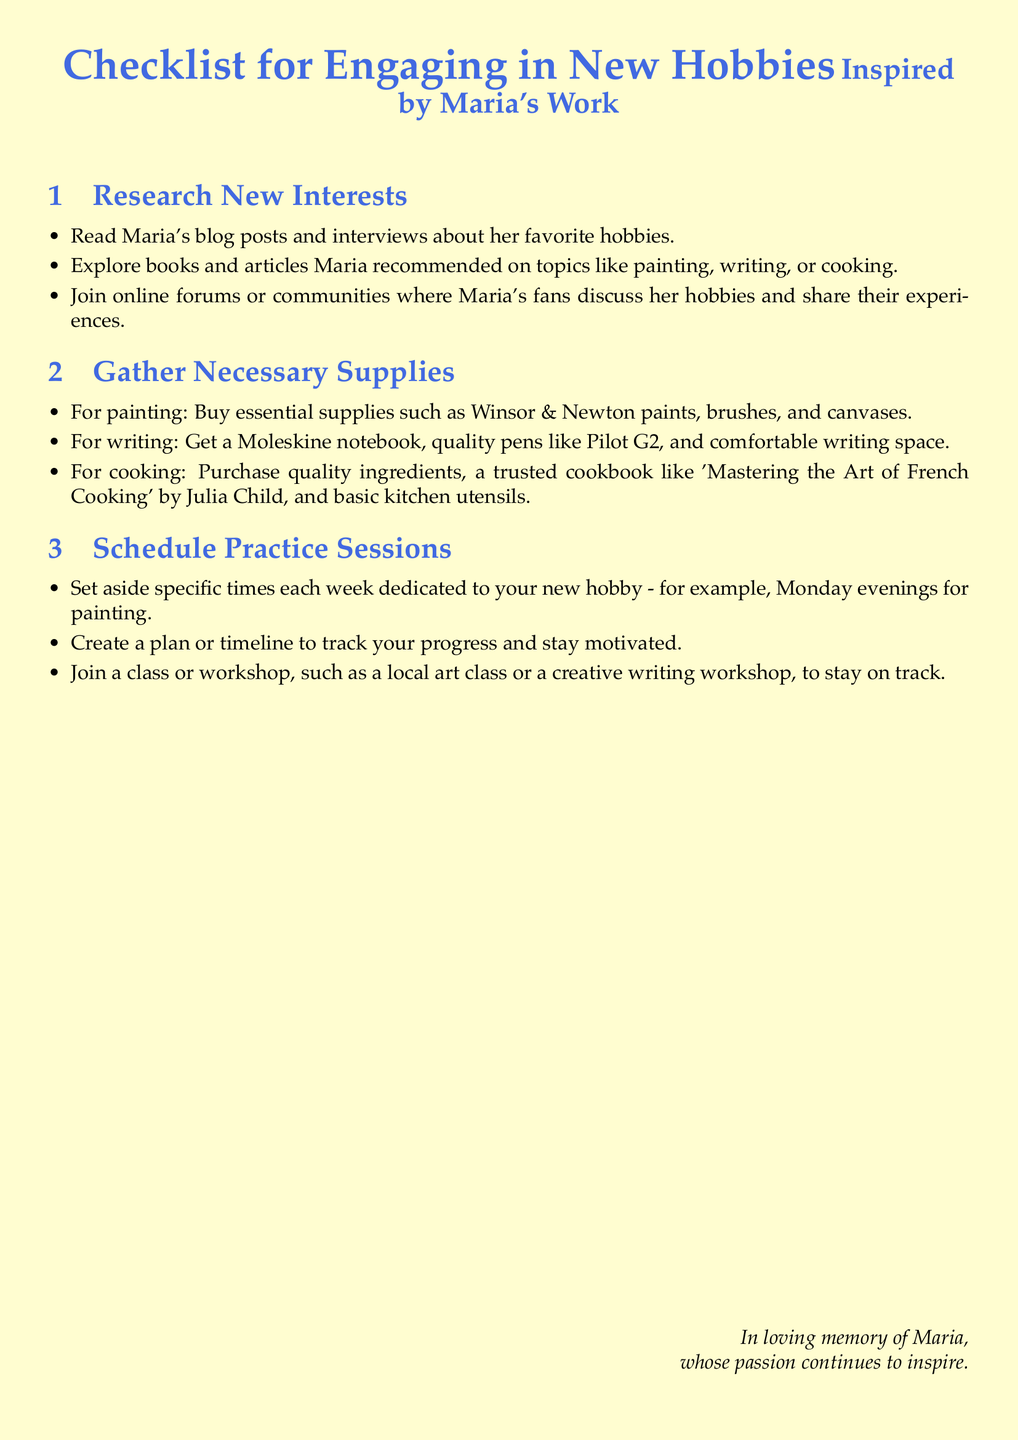What is the main topic of the checklist? The checklist focuses on engaging in new hobbies inspired by Maria's work.
Answer: New hobbies How many sections are in the checklist? The document has three sections dedicated to different aspects of starting new hobbies.
Answer: Three What is one recommended supply for painting? The document lists essential supplies for painting, including a specific brand of paints.
Answer: Winsor & Newton paints What type of notebook is suggested for writing? The checklist mentions a specific brand of notebook that is recommended for writing.
Answer: Moleskine notebook What is a common activity suggested for practice sessions? The document recommends dedicating specific times each week to practice a new hobby.
Answer: Specific times What cookbook is mentioned for cooking? The checklist includes a famous cookbook that is suggested for culinary enthusiasts.
Answer: Mastering the Art of French Cooking What kind of communities does the document suggest joining? The checklist encourages engaging with fans of Maria's hobbies through specific platforms.
Answer: Online forums What is the purpose of the checklist? The checklist is designed to provide guidance on starting new hobbies inspired by a figure admired by the fans.
Answer: Guidance 